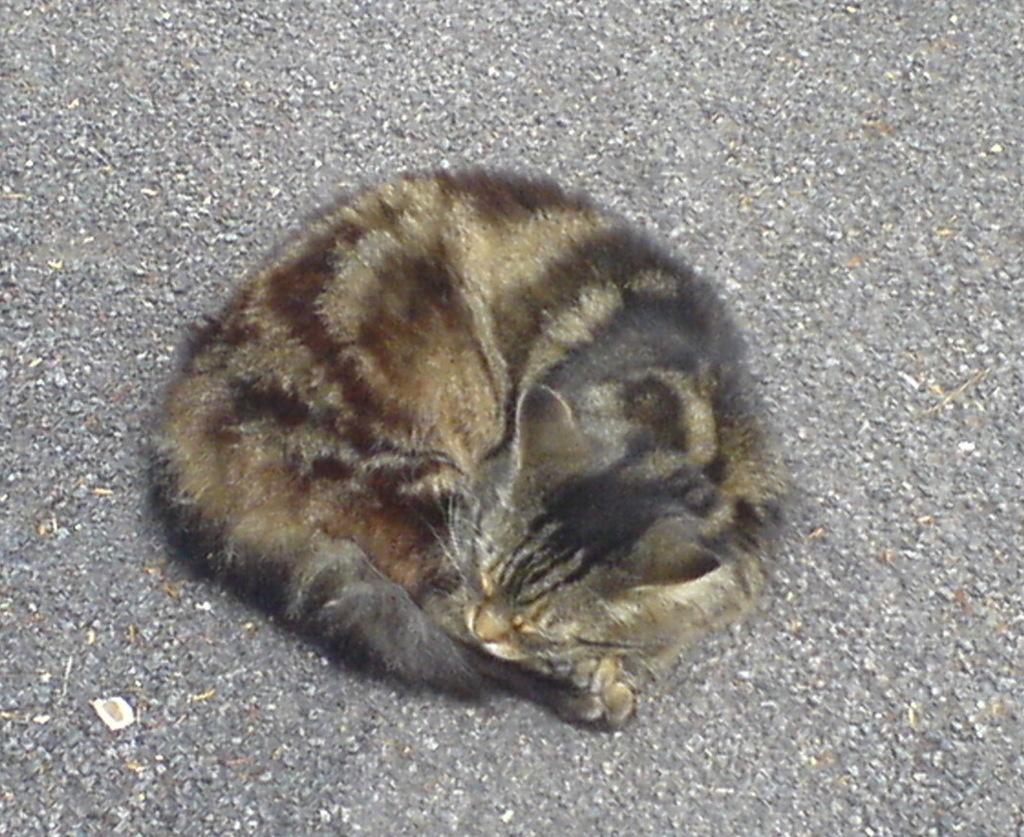Can you describe this image briefly? This image is taken outdoors. At the bottom of the image there is a road. In the middle of the image there is a cat on the road. 